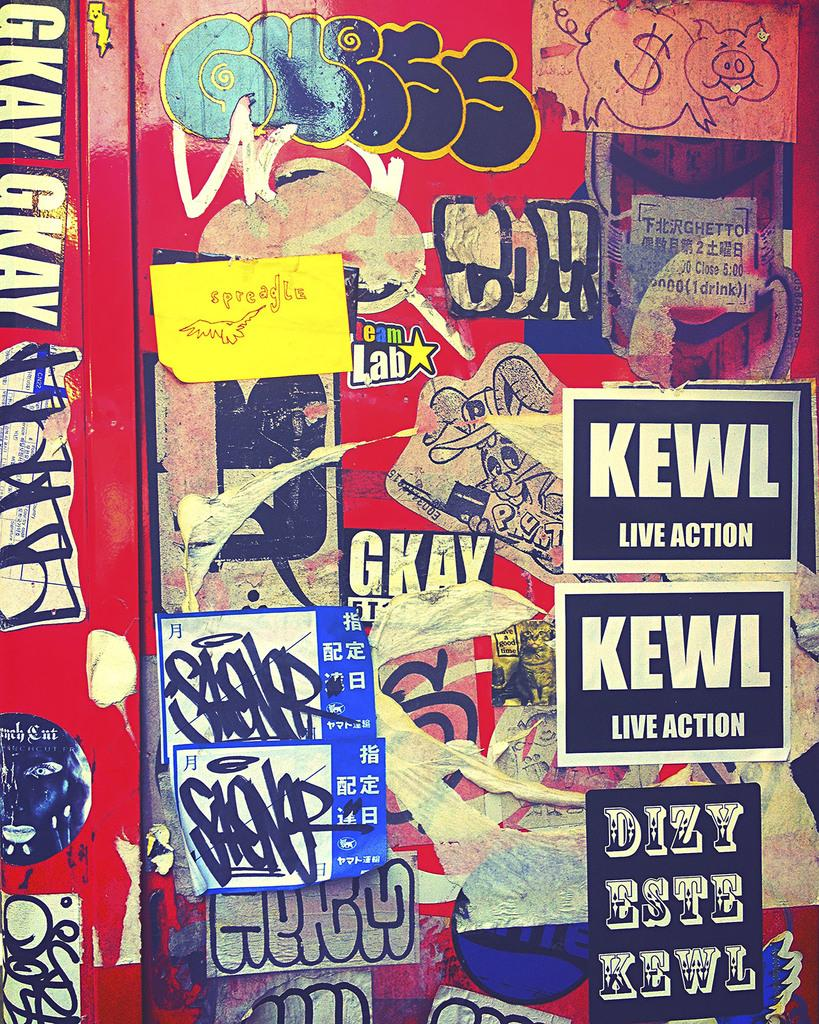<image>
Provide a brief description of the given image. Stickers on a red wall including one that says KEWL. 